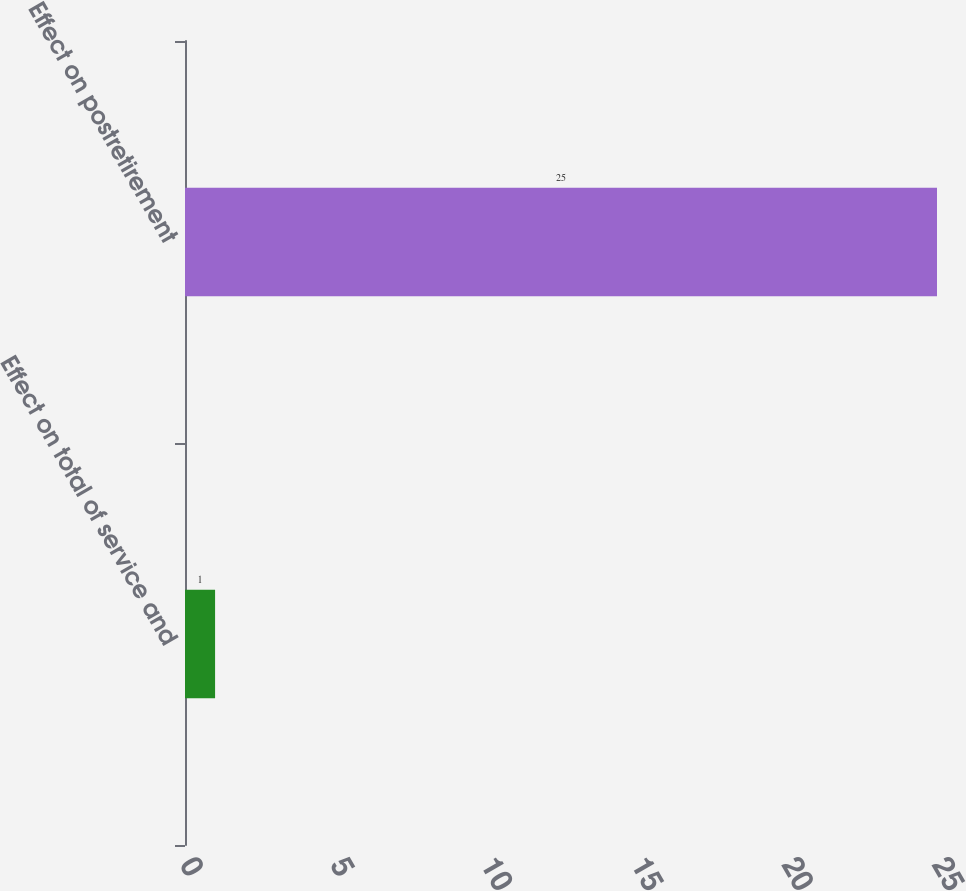<chart> <loc_0><loc_0><loc_500><loc_500><bar_chart><fcel>Effect on total of service and<fcel>Effect on postretirement<nl><fcel>1<fcel>25<nl></chart> 